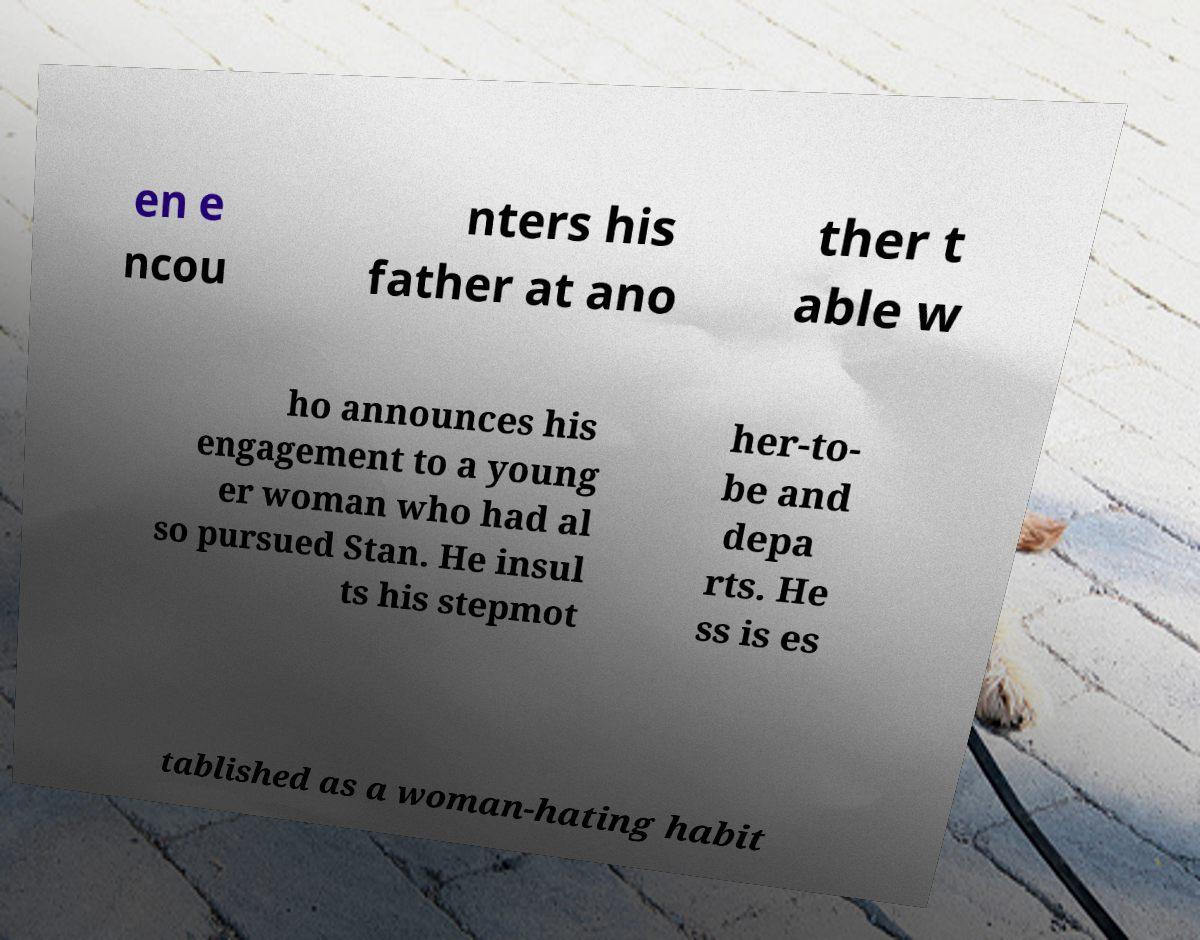Can you accurately transcribe the text from the provided image for me? en e ncou nters his father at ano ther t able w ho announces his engagement to a young er woman who had al so pursued Stan. He insul ts his stepmot her-to- be and depa rts. He ss is es tablished as a woman-hating habit 